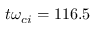<formula> <loc_0><loc_0><loc_500><loc_500>t \omega _ { c i } = 1 1 6 . 5</formula> 